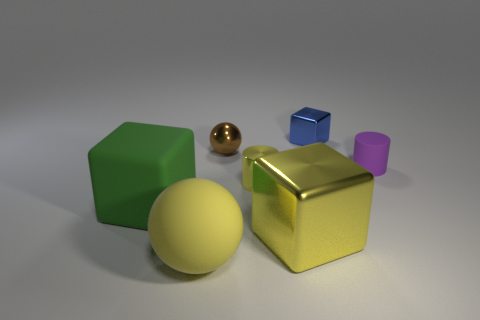There is a tiny thing behind the small brown metallic ball; is its shape the same as the big yellow shiny thing? The tiny object behind the small brown metallic ball has a different shape compared to the large yellow shiny object. While the small object appears to have a circular form akin to a ball, the larger yellow object has the shape of a cube, with six square faces and edges distinctly visible. 